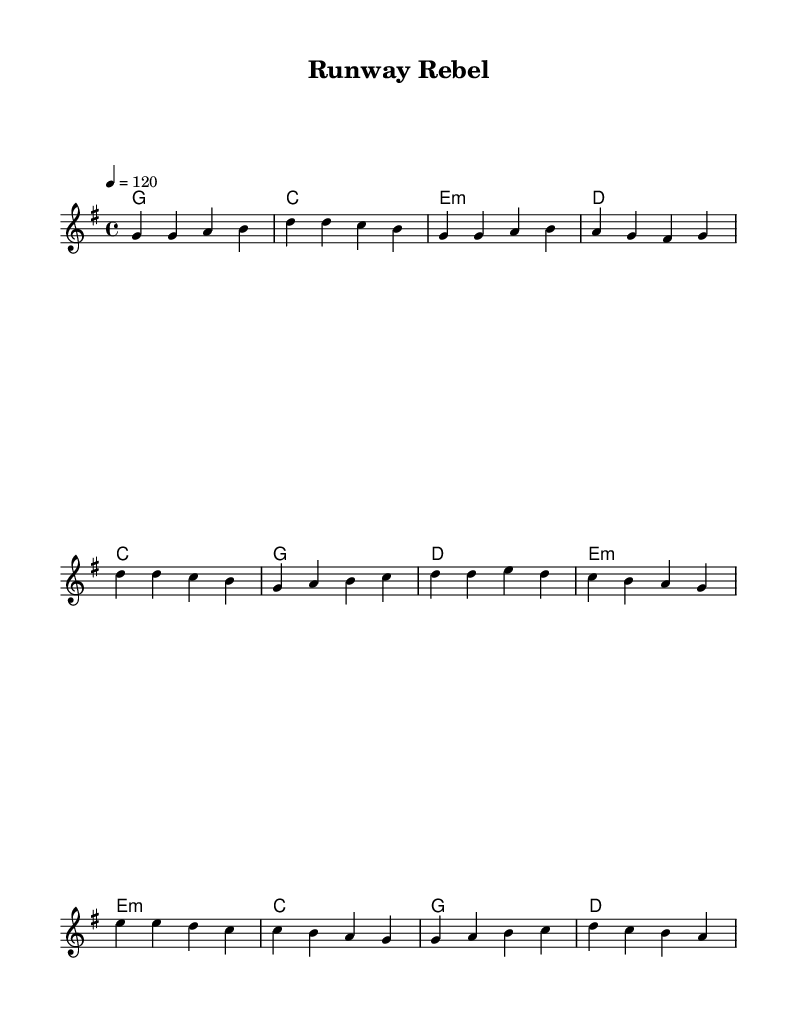What is the key signature of this music? The key signature is G major, which has one sharp (F#).
Answer: G major What is the time signature of this music? The time signature is 4/4, which means there are four beats per measure.
Answer: 4/4 What is the tempo marking indicated in the score? The tempo marking is indicated as 120 beats per minute, meaning the piece is played at a moderate pace.
Answer: 120 What is the main theme of the song as reflected in the lyrics? The lyrics express a defiance against fashion norms and an embrace of individuality, suggesting a concept of breaking rules.
Answer: Breaking rules How many sections are in the song according to the structure? The song consists of three distinct sections: the verse, chorus, and bridge. This creates a dynamic flow and contrast in the music.
Answer: Three What kind of harmony is used in the verse? The harmony in the verse uses major and minor chords, which provide a balance between brightness and tension, fitting the rebellious theme.
Answer: Major and minor chords What is the recurring phrase of the chorus? The recurring phrase captures the spirit of rebellion and individualism in fashion, defining the essence of a "runway rebel."
Answer: Runway rebel 